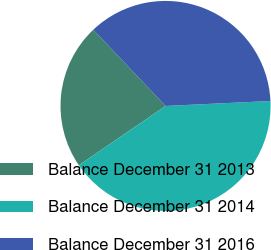Convert chart to OTSL. <chart><loc_0><loc_0><loc_500><loc_500><pie_chart><fcel>Balance December 31 2013<fcel>Balance December 31 2014<fcel>Balance December 31 2016<nl><fcel>22.47%<fcel>41.2%<fcel>36.33%<nl></chart> 